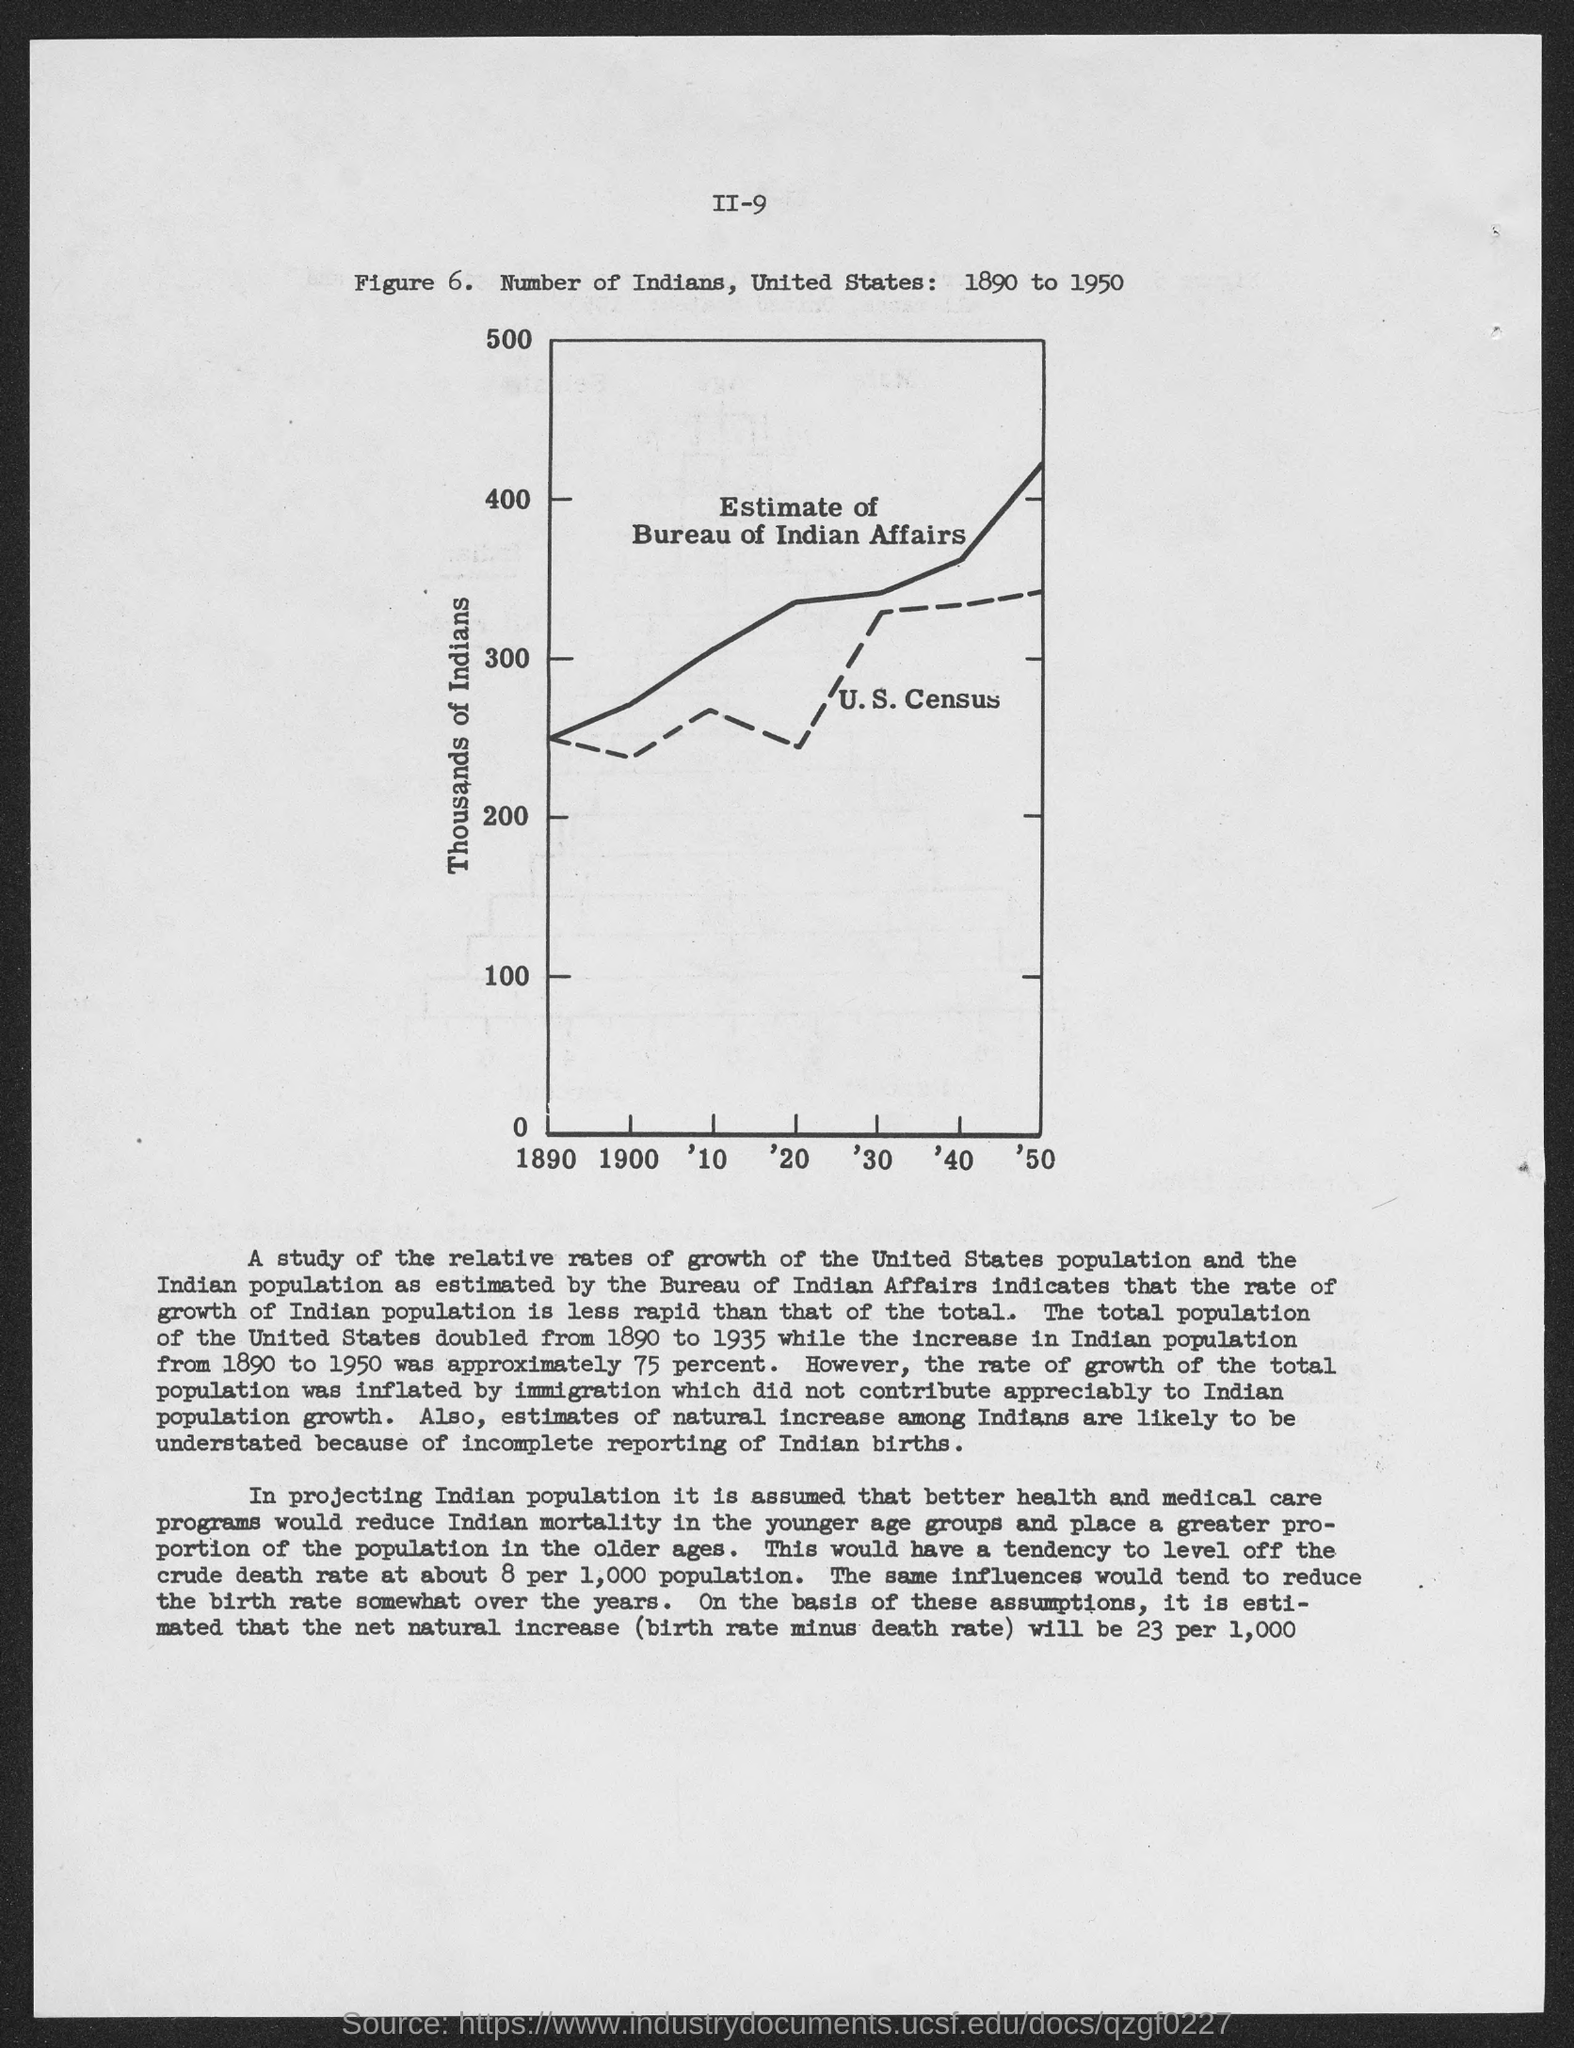What is the figure no.?
Your answer should be compact. 6. What is the written on the y- axis of the figure?
Your answer should be compact. Thousands of indians. 